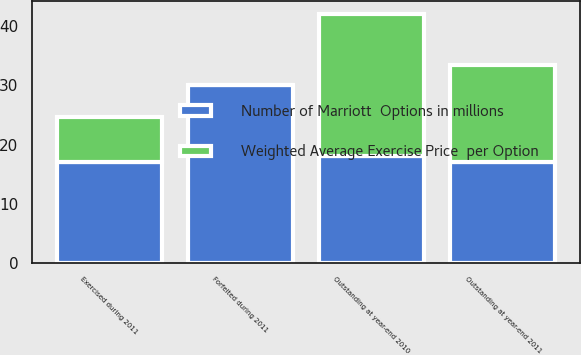Convert chart. <chart><loc_0><loc_0><loc_500><loc_500><stacked_bar_chart><ecel><fcel>Outstanding at year-end 2010<fcel>Exercised during 2011<fcel>Forfeited during 2011<fcel>Outstanding at year-end 2011<nl><fcel>Weighted Average Exercise Price  per Option<fcel>24.1<fcel>7.6<fcel>0.1<fcel>16.4<nl><fcel>Number of Marriott  Options in millions<fcel>18<fcel>17<fcel>30<fcel>17<nl></chart> 